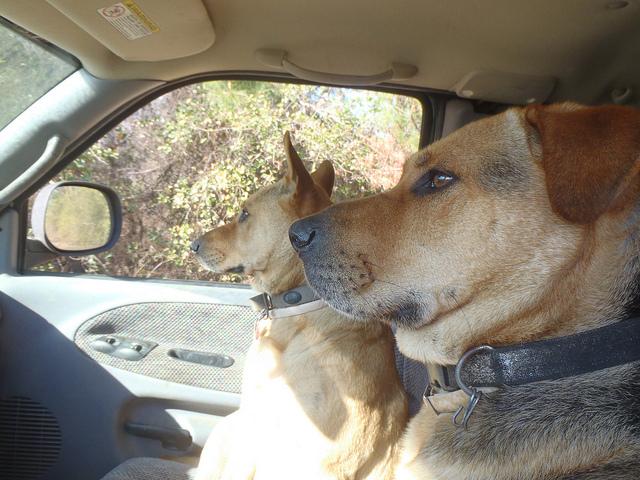What kind of vehicle is the dog sitting in?
Write a very short answer. Car. Is the background of a city?
Keep it brief. No. Is this a golden retriever?
Keep it brief. No. What is the name of the dog?
Quick response, please. German shepherd. How many dogs are in this scene?
Keep it brief. 2. Does the dog have it's license?
Quick response, please. No. Is the dog large or small?
Give a very brief answer. Large. What is the dog riding?
Short answer required. Car. Are both dog's ears erect?
Be succinct. No. Why are their especially large mirrors on the side of the vehicle?
Write a very short answer. Safety. What is reflected in the mirror?
Short answer required. Trees. Where IS THIS DOG?
Answer briefly. In car. What color is the dog's tag?
Quick response, please. Black. Who is driving the vehicle?
Concise answer only. Dog. Is the dog thirsty?
Be succinct. No. Is the dog in the driver's seat?
Short answer required. Yes. What colors are the dogs?
Give a very brief answer. Brown. What is the dog riding in?
Keep it brief. Car. Is the dog driving?
Keep it brief. Yes. Is the dog looking out of a car window?
Answer briefly. Yes. Do both the dogs have collars on?
Concise answer only. Yes. 